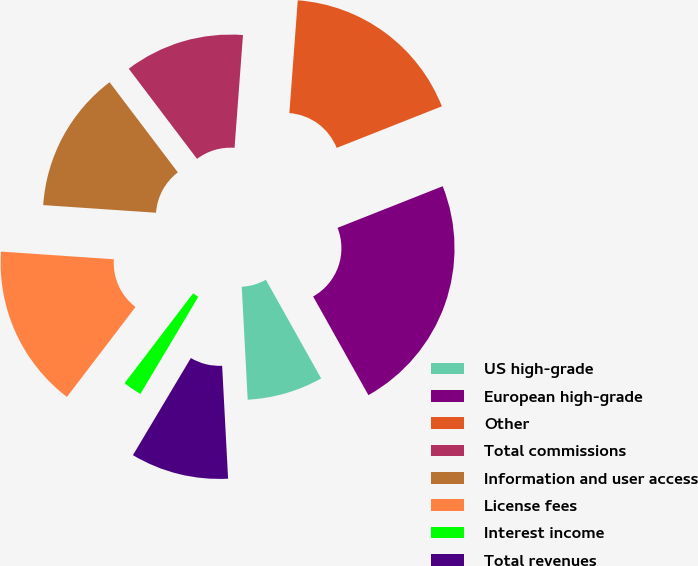Convert chart to OTSL. <chart><loc_0><loc_0><loc_500><loc_500><pie_chart><fcel>US high-grade<fcel>European high-grade<fcel>Other<fcel>Total commissions<fcel>Information and user access<fcel>License fees<fcel>Interest income<fcel>Total revenues<nl><fcel>7.29%<fcel>22.87%<fcel>17.82%<fcel>11.5%<fcel>13.61%<fcel>15.71%<fcel>1.81%<fcel>9.4%<nl></chart> 